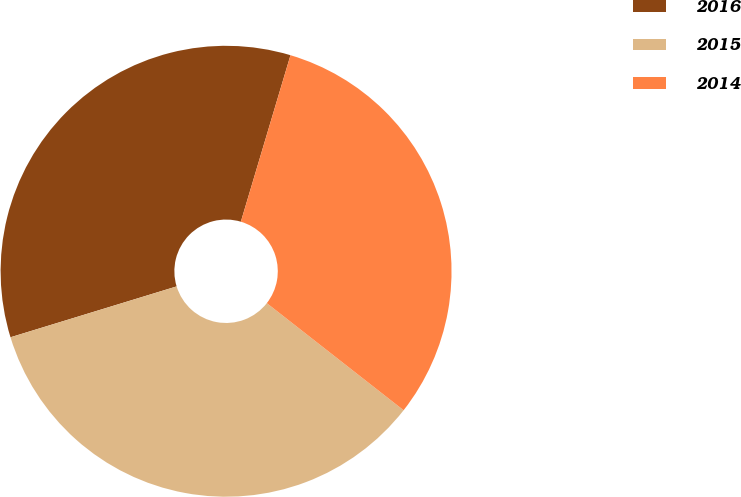Convert chart to OTSL. <chart><loc_0><loc_0><loc_500><loc_500><pie_chart><fcel>2016<fcel>2015<fcel>2014<nl><fcel>34.34%<fcel>34.7%<fcel>30.96%<nl></chart> 